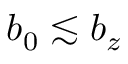<formula> <loc_0><loc_0><loc_500><loc_500>b _ { 0 } \lesssim b _ { z }</formula> 